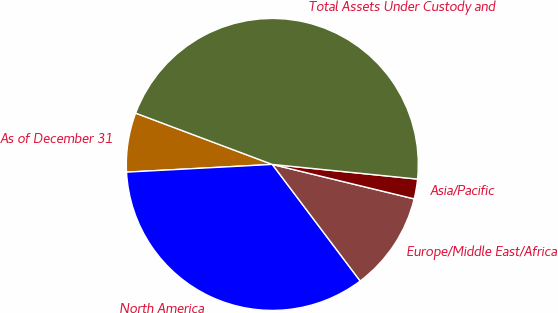Convert chart to OTSL. <chart><loc_0><loc_0><loc_500><loc_500><pie_chart><fcel>As of December 31<fcel>North America<fcel>Europe/Middle East/Africa<fcel>Asia/Pacific<fcel>Total Assets Under Custody and<nl><fcel>6.56%<fcel>34.44%<fcel>10.93%<fcel>2.19%<fcel>45.89%<nl></chart> 